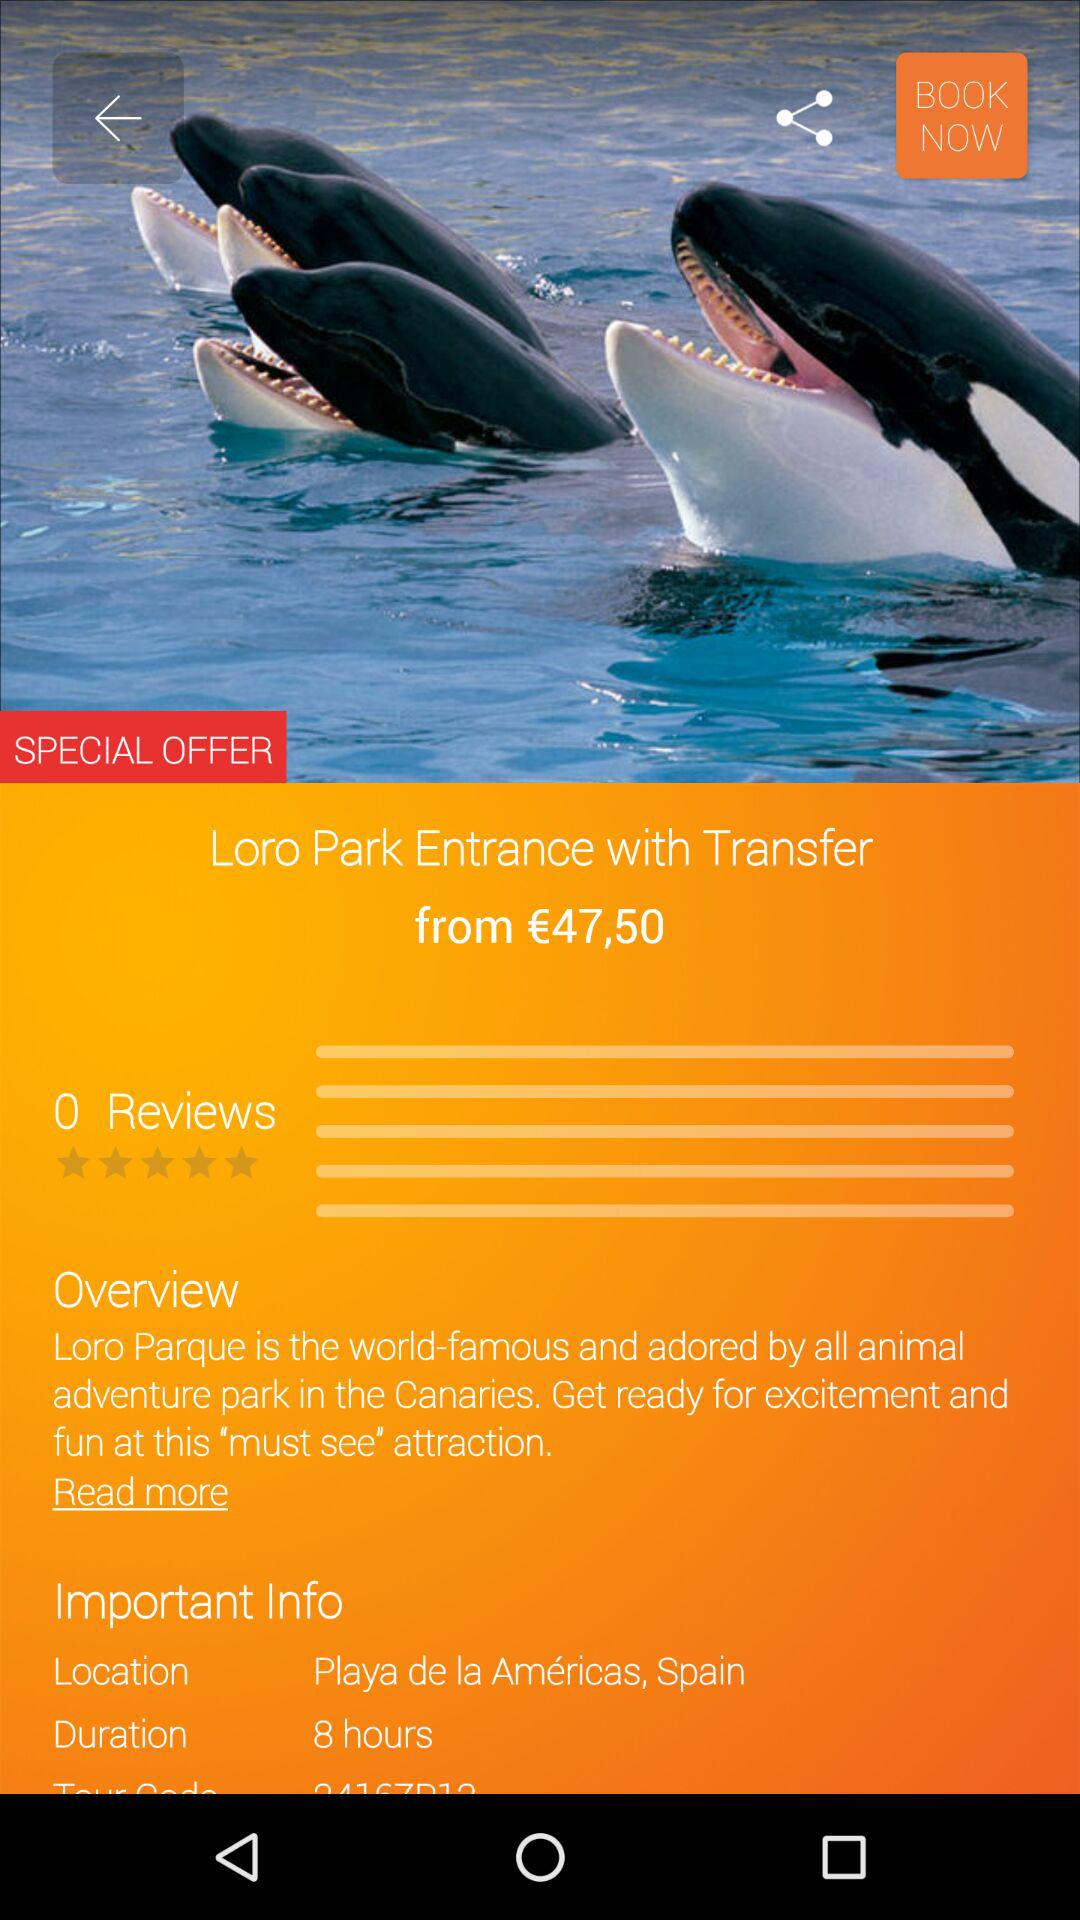What is the special offer?
When the provided information is insufficient, respond with <no answer>. <no answer> 